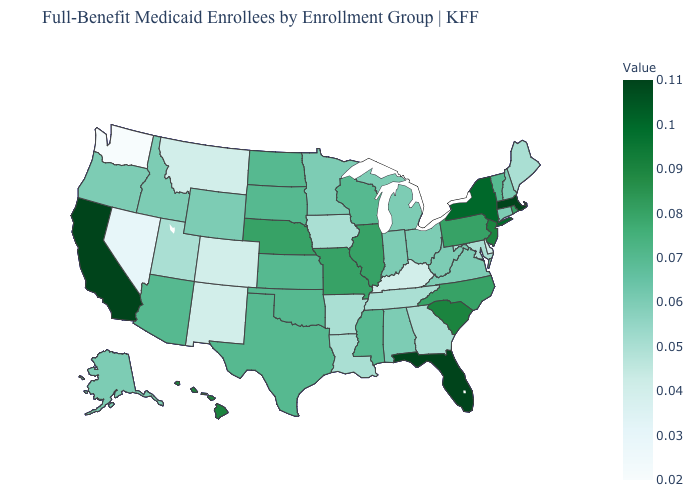Which states have the lowest value in the USA?
Be succinct. Washington. Among the states that border Indiana , does Illinois have the highest value?
Be succinct. Yes. Does Idaho have the highest value in the USA?
Be succinct. No. Does South Dakota have the highest value in the USA?
Keep it brief. No. Which states have the lowest value in the West?
Quick response, please. Washington. Does Rhode Island have a lower value than New York?
Keep it brief. Yes. Among the states that border Wisconsin , does Illinois have the highest value?
Quick response, please. Yes. 